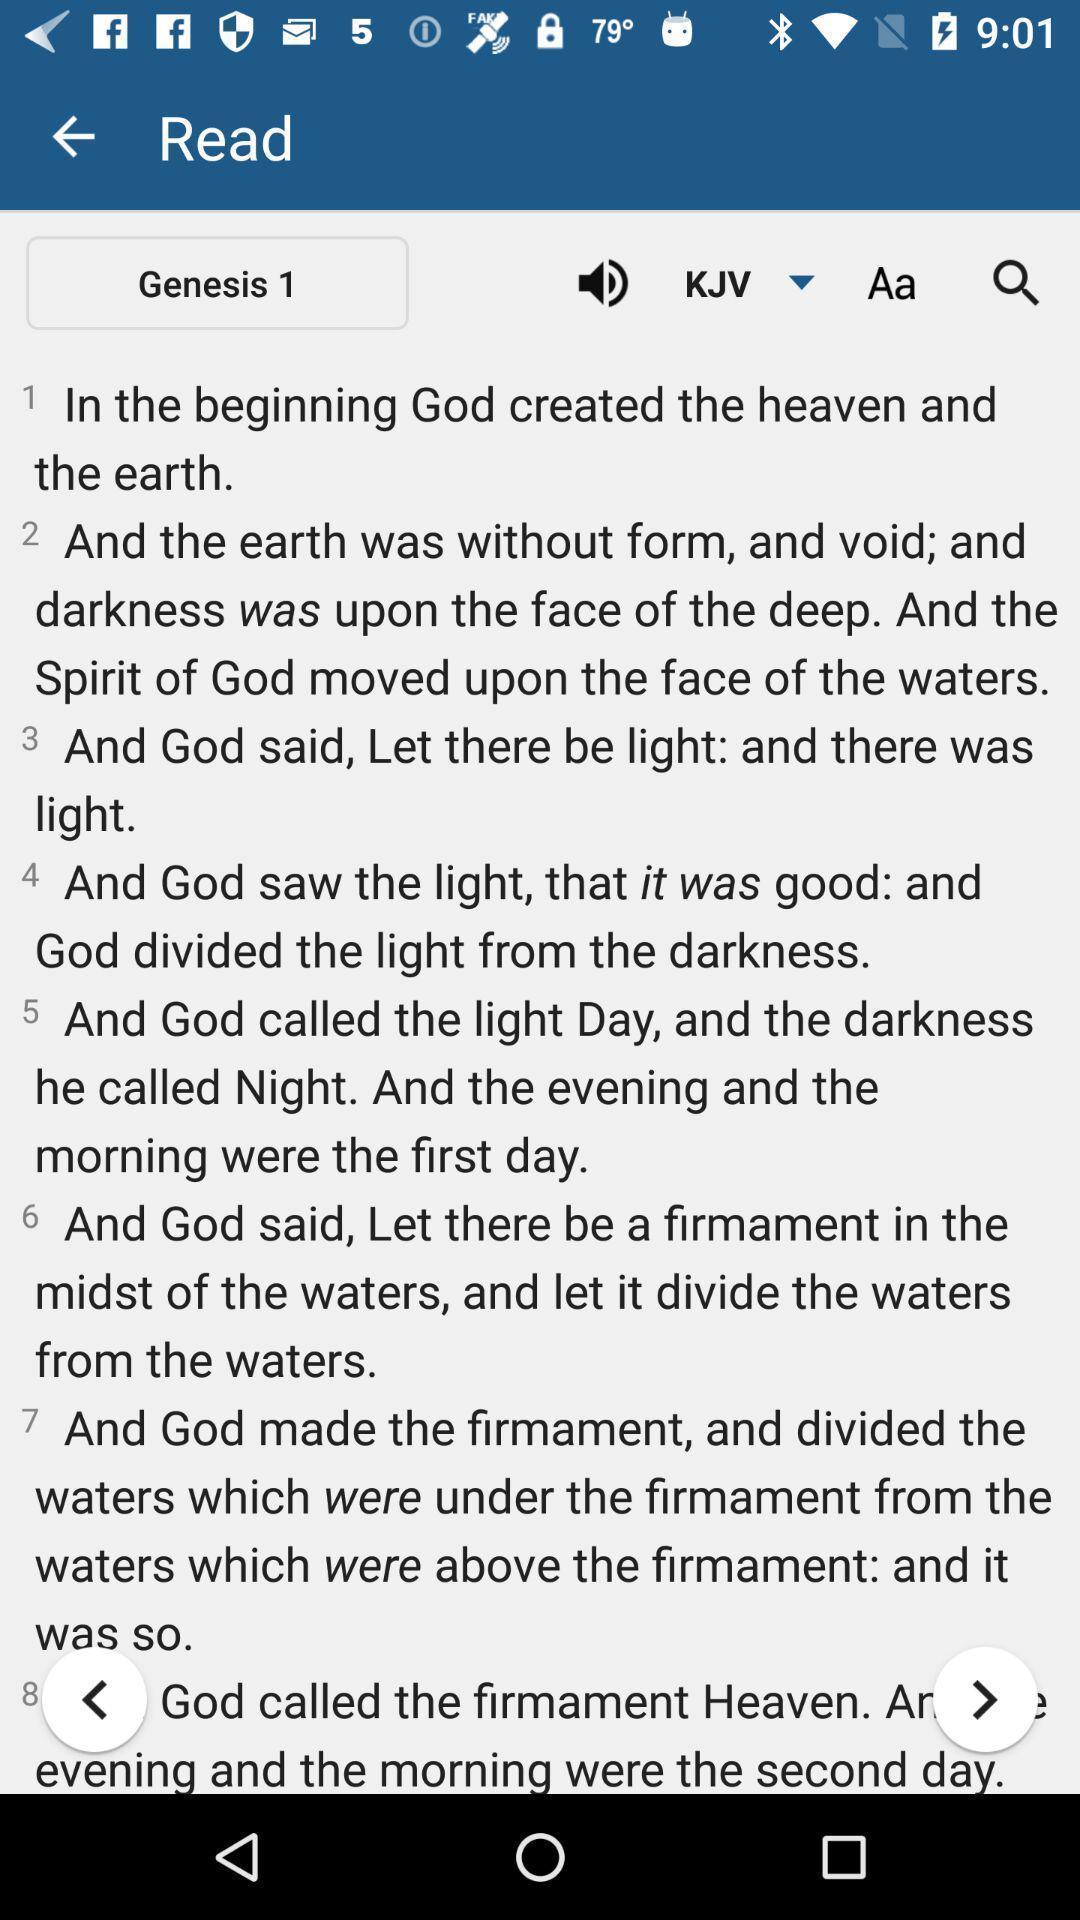Describe the key features of this screenshot. Various verses displayed of a religious ebook app. 